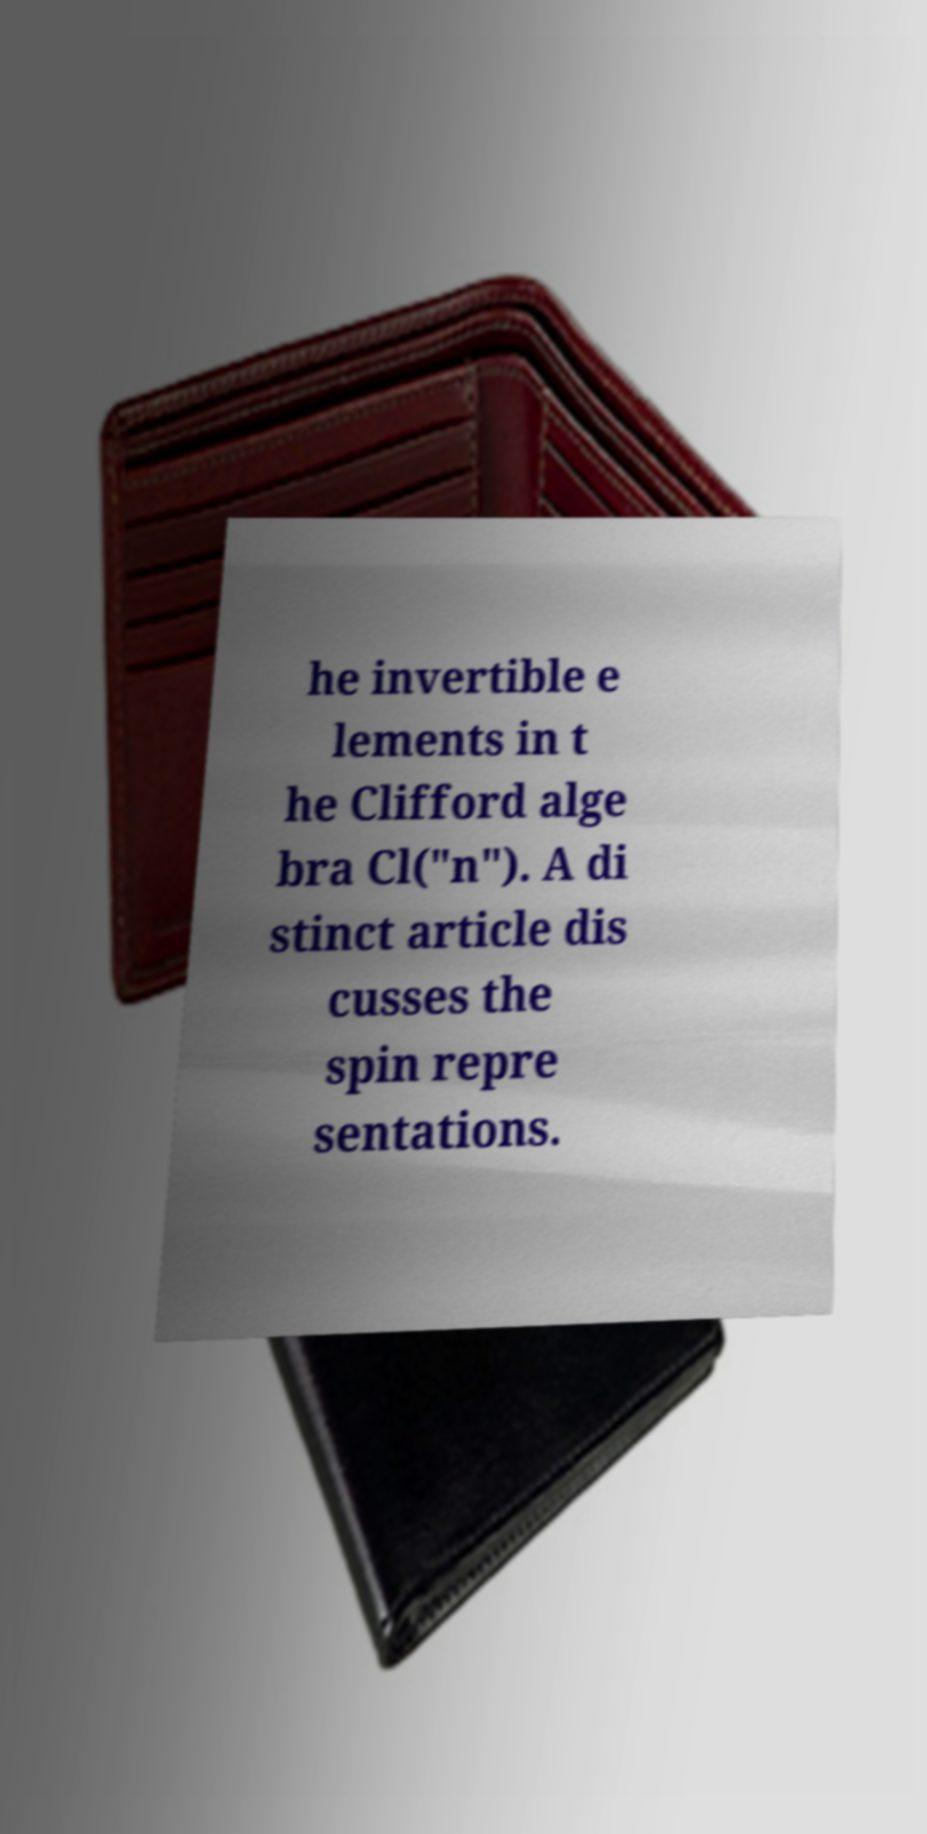I need the written content from this picture converted into text. Can you do that? he invertible e lements in t he Clifford alge bra Cl("n"). A di stinct article dis cusses the spin repre sentations. 